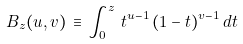Convert formula to latex. <formula><loc_0><loc_0><loc_500><loc_500>B _ { z } ( u , v ) \, \equiv \, \int _ { 0 } ^ { z } \, t ^ { u - 1 } \, ( 1 - t ) ^ { v - 1 } \, d t</formula> 